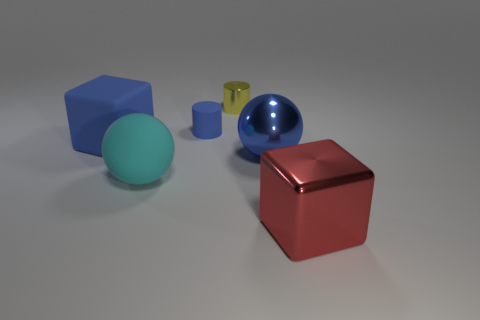What shape is the big rubber thing that is the same color as the rubber cylinder?
Provide a short and direct response. Cube. Is there a small cylinder of the same color as the big matte block?
Ensure brevity in your answer.  Yes. Does the sphere right of the blue cylinder have the same material as the tiny blue object?
Make the answer very short. No. The tiny thing left of the small thing to the right of the tiny rubber thing that is on the left side of the big red metal block is what shape?
Offer a very short reply. Cylinder. How many gray objects are large cylinders or rubber things?
Give a very brief answer. 0. Are there the same number of large red cubes behind the yellow cylinder and large blue shiny objects that are in front of the big shiny sphere?
Your response must be concise. Yes. There is a cyan object in front of the big blue matte thing; does it have the same shape as the blue rubber thing that is to the right of the big cyan ball?
Offer a terse response. No. There is another small object that is made of the same material as the red thing; what is its shape?
Ensure brevity in your answer.  Cylinder. Are there the same number of tiny blue objects that are to the right of the blue cylinder and red things?
Provide a succinct answer. No. Do the block left of the red cube and the cube in front of the blue shiny thing have the same material?
Ensure brevity in your answer.  No. 